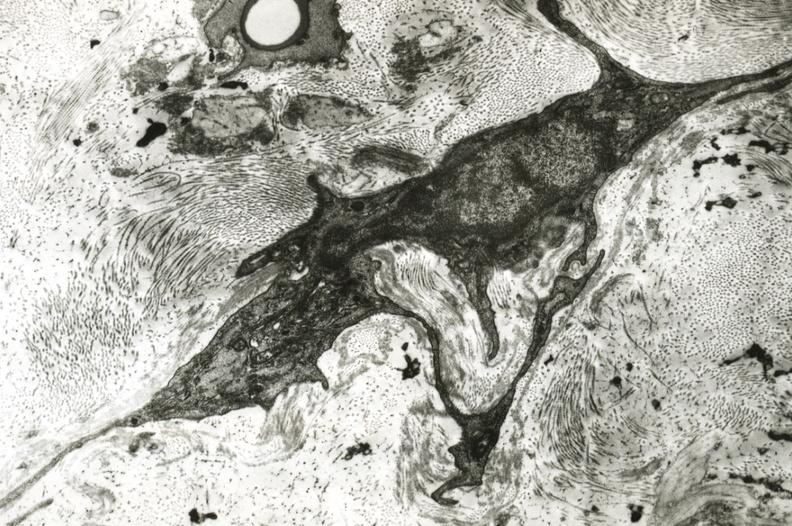where is this?
Answer the question using a single word or phrase. Vasculature 